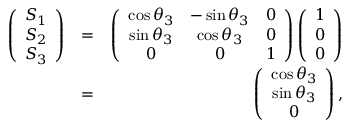<formula> <loc_0><loc_0><loc_500><loc_500>\begin{array} { r l r } { \left ( \begin{array} { c } { S _ { 1 } } \\ { S _ { 2 } } \\ { S _ { 3 } } \end{array} \right ) } & { = } & { \left ( \begin{array} { c c c } { \cos \theta _ { 3 } } & { - \sin \theta _ { 3 } } & { 0 } \\ { \sin \theta _ { 3 } } & { \cos \theta _ { 3 } } & { 0 } \\ { 0 } & { 0 } & { 1 } \end{array} \right ) \left ( \begin{array} { c } { 1 } \\ { 0 } \\ { 0 } \end{array} \right ) } \\ & { = } & { \left ( \begin{array} { c } { \cos \theta _ { 3 } } \\ { \sin \theta _ { 3 } } \\ { 0 } \end{array} \right ) , } \end{array}</formula> 